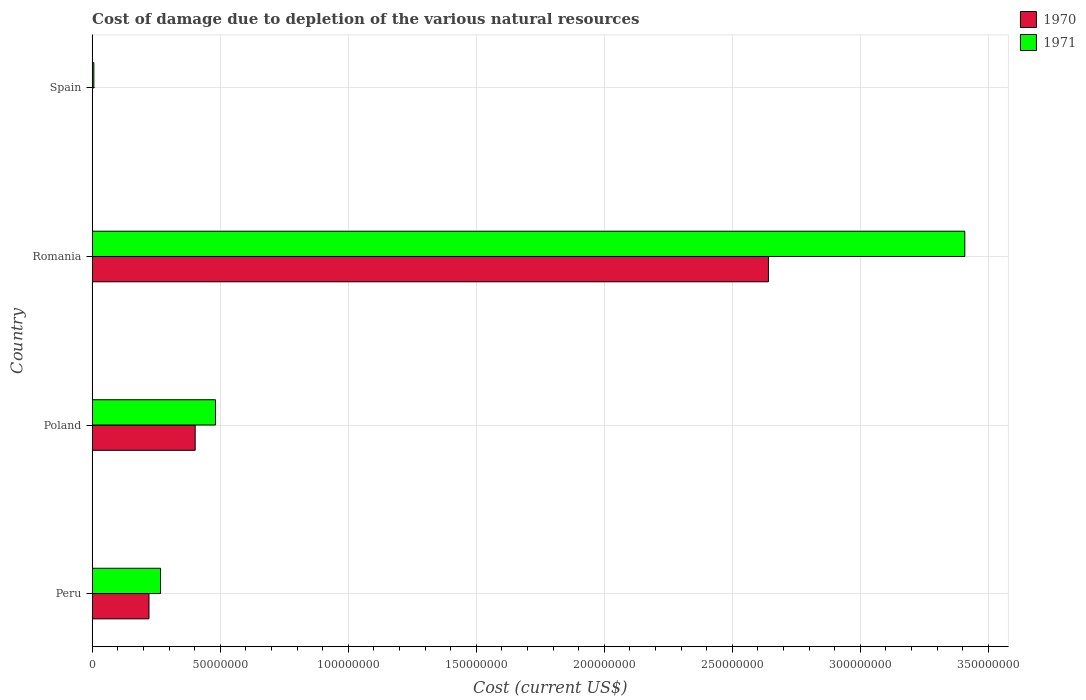How many different coloured bars are there?
Keep it short and to the point. 2. Are the number of bars per tick equal to the number of legend labels?
Your answer should be very brief. Yes. Are the number of bars on each tick of the Y-axis equal?
Your answer should be very brief. Yes. How many bars are there on the 2nd tick from the top?
Provide a succinct answer. 2. What is the cost of damage caused due to the depletion of various natural resources in 1970 in Peru?
Offer a very short reply. 2.22e+07. Across all countries, what is the maximum cost of damage caused due to the depletion of various natural resources in 1970?
Your answer should be very brief. 2.64e+08. Across all countries, what is the minimum cost of damage caused due to the depletion of various natural resources in 1971?
Offer a very short reply. 6.25e+05. In which country was the cost of damage caused due to the depletion of various natural resources in 1971 maximum?
Your answer should be very brief. Romania. What is the total cost of damage caused due to the depletion of various natural resources in 1970 in the graph?
Provide a short and direct response. 3.26e+08. What is the difference between the cost of damage caused due to the depletion of various natural resources in 1971 in Poland and that in Romania?
Your response must be concise. -2.93e+08. What is the difference between the cost of damage caused due to the depletion of various natural resources in 1971 in Poland and the cost of damage caused due to the depletion of various natural resources in 1970 in Romania?
Ensure brevity in your answer.  -2.16e+08. What is the average cost of damage caused due to the depletion of various natural resources in 1971 per country?
Ensure brevity in your answer.  1.04e+08. What is the difference between the cost of damage caused due to the depletion of various natural resources in 1971 and cost of damage caused due to the depletion of various natural resources in 1970 in Poland?
Keep it short and to the point. 7.95e+06. In how many countries, is the cost of damage caused due to the depletion of various natural resources in 1970 greater than 270000000 US$?
Your response must be concise. 0. What is the ratio of the cost of damage caused due to the depletion of various natural resources in 1971 in Peru to that in Romania?
Your answer should be compact. 0.08. Is the difference between the cost of damage caused due to the depletion of various natural resources in 1971 in Poland and Romania greater than the difference between the cost of damage caused due to the depletion of various natural resources in 1970 in Poland and Romania?
Ensure brevity in your answer.  No. What is the difference between the highest and the second highest cost of damage caused due to the depletion of various natural resources in 1970?
Your answer should be compact. 2.24e+08. What is the difference between the highest and the lowest cost of damage caused due to the depletion of various natural resources in 1971?
Your answer should be compact. 3.40e+08. What does the 2nd bar from the top in Romania represents?
Offer a very short reply. 1970. What does the 1st bar from the bottom in Romania represents?
Make the answer very short. 1970. How many bars are there?
Your response must be concise. 8. How many countries are there in the graph?
Provide a short and direct response. 4. Are the values on the major ticks of X-axis written in scientific E-notation?
Your answer should be very brief. No. Where does the legend appear in the graph?
Provide a succinct answer. Top right. How many legend labels are there?
Ensure brevity in your answer.  2. How are the legend labels stacked?
Your answer should be compact. Vertical. What is the title of the graph?
Your answer should be compact. Cost of damage due to depletion of the various natural resources. Does "1977" appear as one of the legend labels in the graph?
Offer a very short reply. No. What is the label or title of the X-axis?
Your answer should be compact. Cost (current US$). What is the label or title of the Y-axis?
Offer a terse response. Country. What is the Cost (current US$) of 1970 in Peru?
Give a very brief answer. 2.22e+07. What is the Cost (current US$) in 1971 in Peru?
Your answer should be very brief. 2.67e+07. What is the Cost (current US$) of 1970 in Poland?
Your answer should be compact. 4.02e+07. What is the Cost (current US$) in 1971 in Poland?
Your answer should be compact. 4.82e+07. What is the Cost (current US$) in 1970 in Romania?
Offer a very short reply. 2.64e+08. What is the Cost (current US$) of 1971 in Romania?
Make the answer very short. 3.41e+08. What is the Cost (current US$) of 1970 in Spain?
Your response must be concise. 1.78e+04. What is the Cost (current US$) of 1971 in Spain?
Your answer should be compact. 6.25e+05. Across all countries, what is the maximum Cost (current US$) of 1970?
Give a very brief answer. 2.64e+08. Across all countries, what is the maximum Cost (current US$) in 1971?
Offer a terse response. 3.41e+08. Across all countries, what is the minimum Cost (current US$) in 1970?
Make the answer very short. 1.78e+04. Across all countries, what is the minimum Cost (current US$) in 1971?
Keep it short and to the point. 6.25e+05. What is the total Cost (current US$) in 1970 in the graph?
Your answer should be very brief. 3.26e+08. What is the total Cost (current US$) in 1971 in the graph?
Give a very brief answer. 4.16e+08. What is the difference between the Cost (current US$) of 1970 in Peru and that in Poland?
Your answer should be very brief. -1.80e+07. What is the difference between the Cost (current US$) of 1971 in Peru and that in Poland?
Make the answer very short. -2.15e+07. What is the difference between the Cost (current US$) of 1970 in Peru and that in Romania?
Offer a terse response. -2.42e+08. What is the difference between the Cost (current US$) in 1971 in Peru and that in Romania?
Your response must be concise. -3.14e+08. What is the difference between the Cost (current US$) of 1970 in Peru and that in Spain?
Your answer should be very brief. 2.21e+07. What is the difference between the Cost (current US$) in 1971 in Peru and that in Spain?
Your response must be concise. 2.61e+07. What is the difference between the Cost (current US$) in 1970 in Poland and that in Romania?
Your response must be concise. -2.24e+08. What is the difference between the Cost (current US$) of 1971 in Poland and that in Romania?
Your answer should be very brief. -2.93e+08. What is the difference between the Cost (current US$) of 1970 in Poland and that in Spain?
Give a very brief answer. 4.02e+07. What is the difference between the Cost (current US$) of 1971 in Poland and that in Spain?
Provide a short and direct response. 4.75e+07. What is the difference between the Cost (current US$) of 1970 in Romania and that in Spain?
Make the answer very short. 2.64e+08. What is the difference between the Cost (current US$) of 1971 in Romania and that in Spain?
Offer a terse response. 3.40e+08. What is the difference between the Cost (current US$) of 1970 in Peru and the Cost (current US$) of 1971 in Poland?
Keep it short and to the point. -2.60e+07. What is the difference between the Cost (current US$) in 1970 in Peru and the Cost (current US$) in 1971 in Romania?
Your answer should be very brief. -3.19e+08. What is the difference between the Cost (current US$) of 1970 in Peru and the Cost (current US$) of 1971 in Spain?
Give a very brief answer. 2.15e+07. What is the difference between the Cost (current US$) of 1970 in Poland and the Cost (current US$) of 1971 in Romania?
Your response must be concise. -3.01e+08. What is the difference between the Cost (current US$) in 1970 in Poland and the Cost (current US$) in 1971 in Spain?
Your response must be concise. 3.96e+07. What is the difference between the Cost (current US$) in 1970 in Romania and the Cost (current US$) in 1971 in Spain?
Provide a short and direct response. 2.63e+08. What is the average Cost (current US$) of 1970 per country?
Your answer should be very brief. 8.16e+07. What is the average Cost (current US$) of 1971 per country?
Give a very brief answer. 1.04e+08. What is the difference between the Cost (current US$) of 1970 and Cost (current US$) of 1971 in Peru?
Make the answer very short. -4.53e+06. What is the difference between the Cost (current US$) in 1970 and Cost (current US$) in 1971 in Poland?
Provide a succinct answer. -7.95e+06. What is the difference between the Cost (current US$) of 1970 and Cost (current US$) of 1971 in Romania?
Your response must be concise. -7.67e+07. What is the difference between the Cost (current US$) in 1970 and Cost (current US$) in 1971 in Spain?
Keep it short and to the point. -6.07e+05. What is the ratio of the Cost (current US$) of 1970 in Peru to that in Poland?
Make the answer very short. 0.55. What is the ratio of the Cost (current US$) of 1971 in Peru to that in Poland?
Give a very brief answer. 0.55. What is the ratio of the Cost (current US$) in 1970 in Peru to that in Romania?
Give a very brief answer. 0.08. What is the ratio of the Cost (current US$) of 1971 in Peru to that in Romania?
Your answer should be very brief. 0.08. What is the ratio of the Cost (current US$) in 1970 in Peru to that in Spain?
Offer a terse response. 1245.27. What is the ratio of the Cost (current US$) in 1971 in Peru to that in Spain?
Ensure brevity in your answer.  42.69. What is the ratio of the Cost (current US$) in 1970 in Poland to that in Romania?
Provide a succinct answer. 0.15. What is the ratio of the Cost (current US$) of 1971 in Poland to that in Romania?
Make the answer very short. 0.14. What is the ratio of the Cost (current US$) of 1970 in Poland to that in Spain?
Your response must be concise. 2259.53. What is the ratio of the Cost (current US$) of 1971 in Poland to that in Spain?
Offer a terse response. 77.04. What is the ratio of the Cost (current US$) in 1970 in Romania to that in Spain?
Provide a short and direct response. 1.48e+04. What is the ratio of the Cost (current US$) in 1971 in Romania to that in Spain?
Make the answer very short. 545.26. What is the difference between the highest and the second highest Cost (current US$) of 1970?
Make the answer very short. 2.24e+08. What is the difference between the highest and the second highest Cost (current US$) in 1971?
Your answer should be very brief. 2.93e+08. What is the difference between the highest and the lowest Cost (current US$) in 1970?
Your answer should be compact. 2.64e+08. What is the difference between the highest and the lowest Cost (current US$) of 1971?
Make the answer very short. 3.40e+08. 